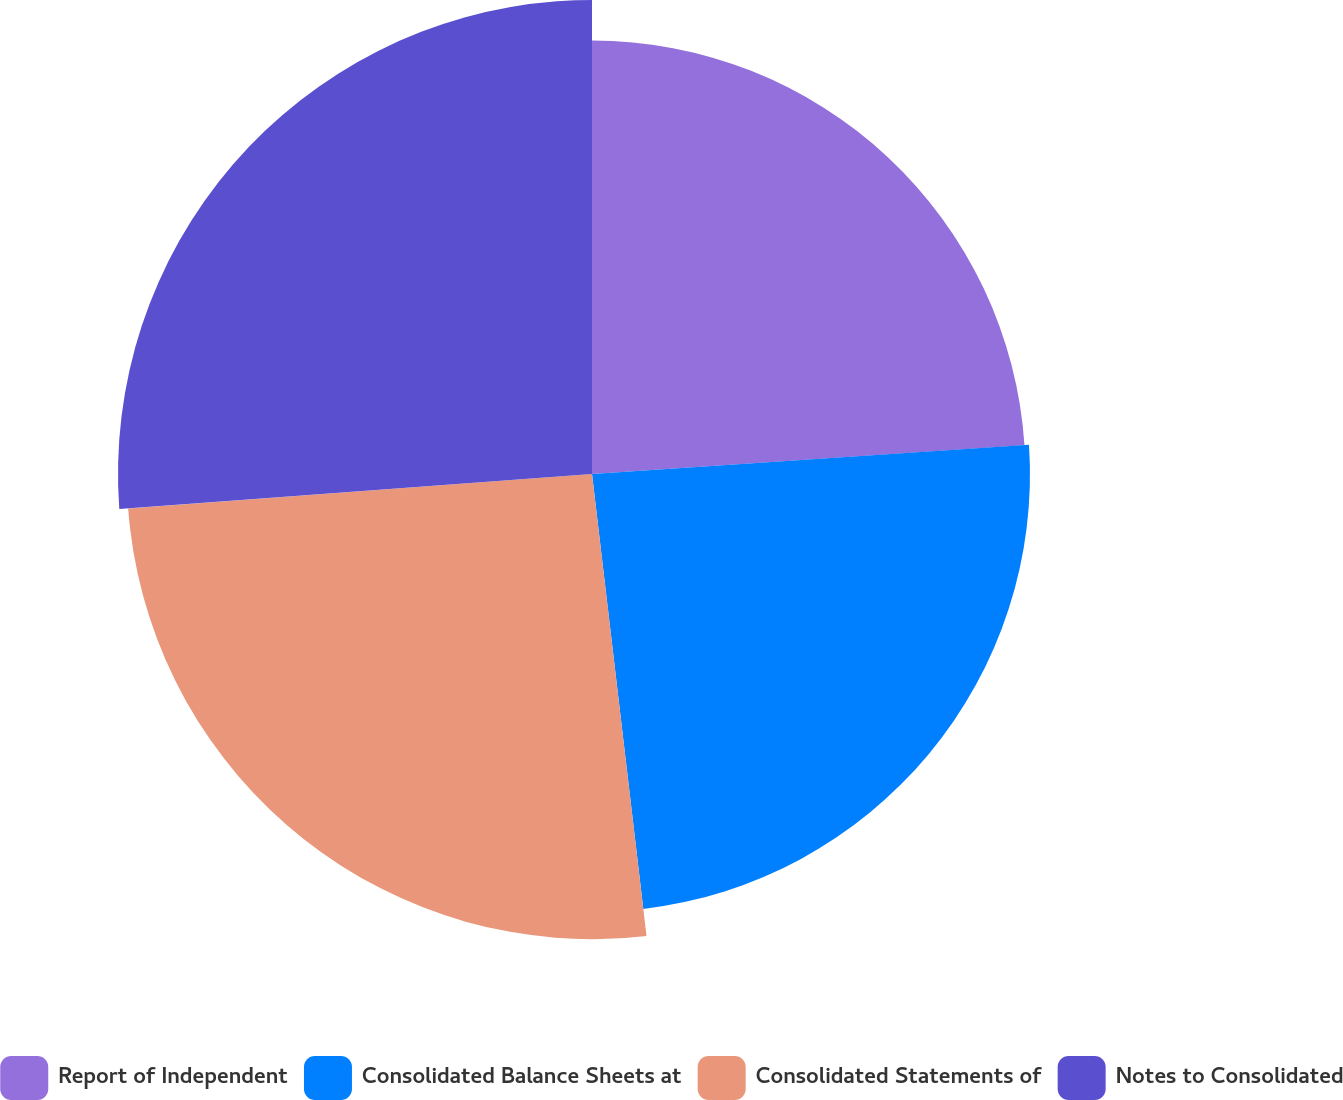Convert chart. <chart><loc_0><loc_0><loc_500><loc_500><pie_chart><fcel>Report of Independent<fcel>Consolidated Balance Sheets at<fcel>Consolidated Statements of<fcel>Notes to Consolidated<nl><fcel>23.94%<fcel>24.19%<fcel>25.69%<fcel>26.18%<nl></chart> 